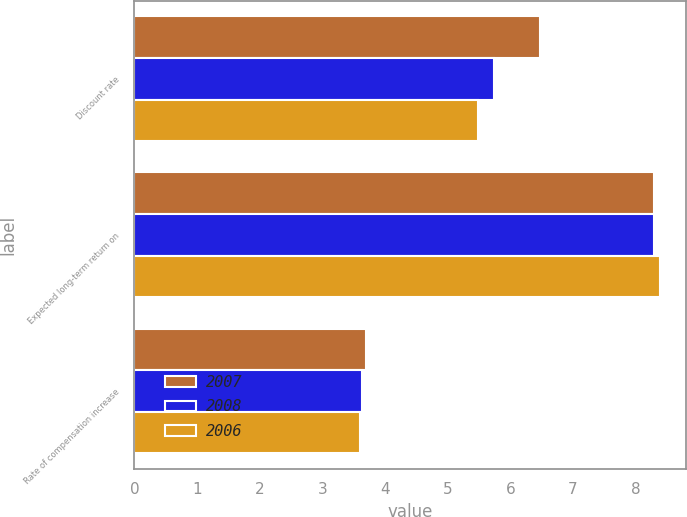Convert chart. <chart><loc_0><loc_0><loc_500><loc_500><stacked_bar_chart><ecel><fcel>Discount rate<fcel>Expected long-term return on<fcel>Rate of compensation increase<nl><fcel>2007<fcel>6.47<fcel>8.29<fcel>3.7<nl><fcel>2008<fcel>5.74<fcel>8.3<fcel>3.63<nl><fcel>2006<fcel>5.49<fcel>8.39<fcel>3.6<nl></chart> 